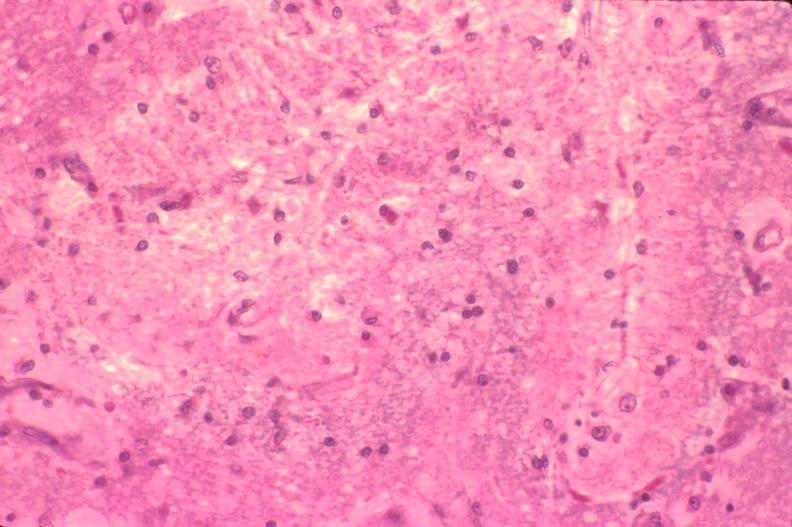where is this?
Answer the question using a single word or phrase. Nervous 